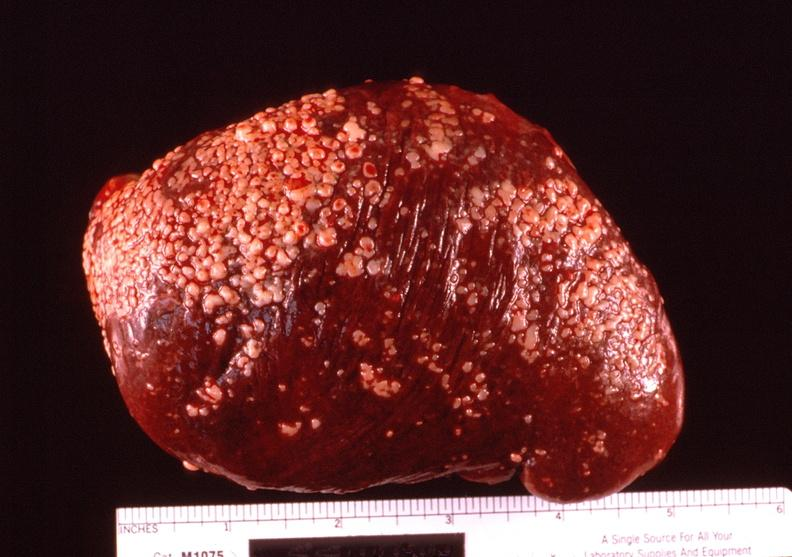where is this part in?
Answer the question using a single word or phrase. Spleen 